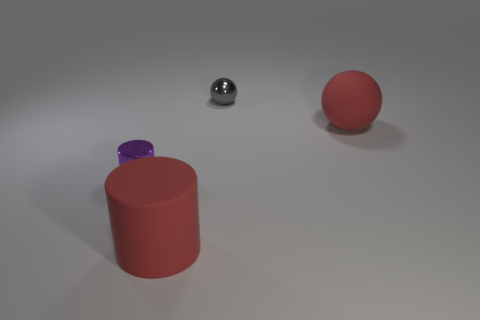What is the shape of the big object that is the same color as the large matte cylinder?
Offer a terse response. Sphere. Is the material of the large red object that is behind the large red cylinder the same as the tiny thing that is in front of the small gray ball?
Make the answer very short. No. What material is the purple cylinder?
Your answer should be very brief. Metal. What number of other objects are the same color as the matte ball?
Your answer should be very brief. 1. Do the large rubber ball and the matte cylinder have the same color?
Ensure brevity in your answer.  Yes. How many big brown metallic blocks are there?
Keep it short and to the point. 0. What is the material of the small thing to the left of the big object that is in front of the tiny shiny cylinder?
Make the answer very short. Metal. What material is the red ball that is the same size as the red cylinder?
Give a very brief answer. Rubber. Does the red object that is in front of the metal cylinder have the same size as the tiny gray ball?
Ensure brevity in your answer.  No. Do the matte object to the left of the gray metal sphere and the purple thing have the same shape?
Your answer should be very brief. Yes. 